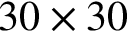Convert formula to latex. <formula><loc_0><loc_0><loc_500><loc_500>3 0 \times 3 0</formula> 